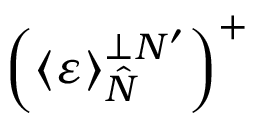Convert formula to latex. <formula><loc_0><loc_0><loc_500><loc_500>\left ( \left \langle \varepsilon \right \rangle _ { \hat { N } } ^ { \perp N ^ { \prime } } \right ) ^ { + }</formula> 